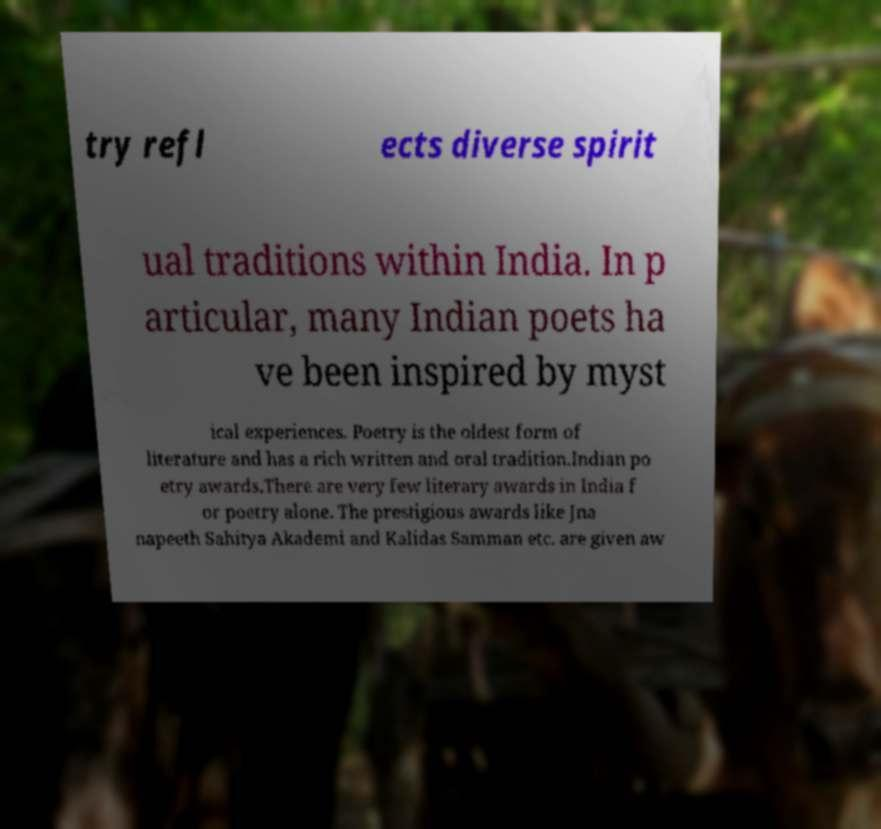Can you accurately transcribe the text from the provided image for me? try refl ects diverse spirit ual traditions within India. In p articular, many Indian poets ha ve been inspired by myst ical experiences. Poetry is the oldest form of literature and has a rich written and oral tradition.Indian po etry awards.There are very few literary awards in India f or poetry alone. The prestigious awards like Jna napeeth Sahitya Akademi and Kalidas Samman etc. are given aw 